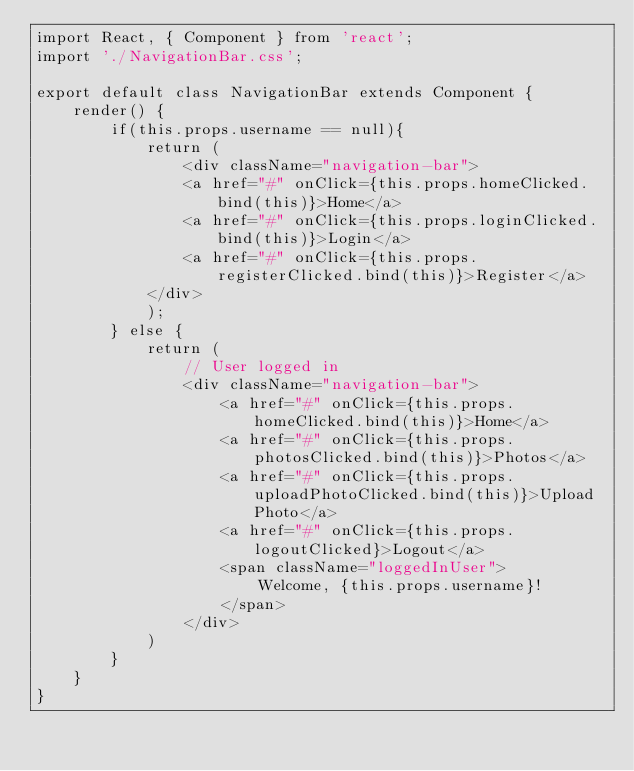Convert code to text. <code><loc_0><loc_0><loc_500><loc_500><_JavaScript_>import React, { Component } from 'react';
import './NavigationBar.css';

export default class NavigationBar extends Component {
    render() {
        if(this.props.username == null){
            return (
                <div className="navigation-bar">
                <a href="#" onClick={this.props.homeClicked.bind(this)}>Home</a>
                <a href="#" onClick={this.props.loginClicked.bind(this)}>Login</a>
                <a href="#" onClick={this.props.registerClicked.bind(this)}>Register</a>
            </div>
            );
        } else {
            return (
                // User logged in
                <div className="navigation-bar">
                    <a href="#" onClick={this.props.homeClicked.bind(this)}>Home</a>
                    <a href="#" onClick={this.props.photosClicked.bind(this)}>Photos</a>
                    <a href="#" onClick={this.props.uploadPhotoClicked.bind(this)}>Upload Photo</a>
                    <a href="#" onClick={this.props.logoutClicked}>Logout</a>
                    <span className="loggedInUser">
                        Welcome, {this.props.username}!
                    </span>
                </div>
            )
        }
    }
}</code> 